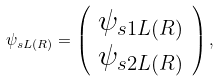Convert formula to latex. <formula><loc_0><loc_0><loc_500><loc_500>\psi _ { s L ( R ) } = \left ( \begin{array} { c } \psi _ { s 1 L ( R ) } \\ \psi _ { s 2 L ( R ) } \end{array} \right ) ,</formula> 